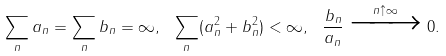Convert formula to latex. <formula><loc_0><loc_0><loc_500><loc_500>\sum _ { n } a _ { n } = \sum _ { n } b _ { n } = \infty , \ \sum _ { n } ( a _ { n } ^ { 2 } + b _ { n } ^ { 2 } ) < \infty , \ \frac { b _ { n } } { a _ { n } } \xrightarrow [ ] { n \uparrow \infty } 0 .</formula> 